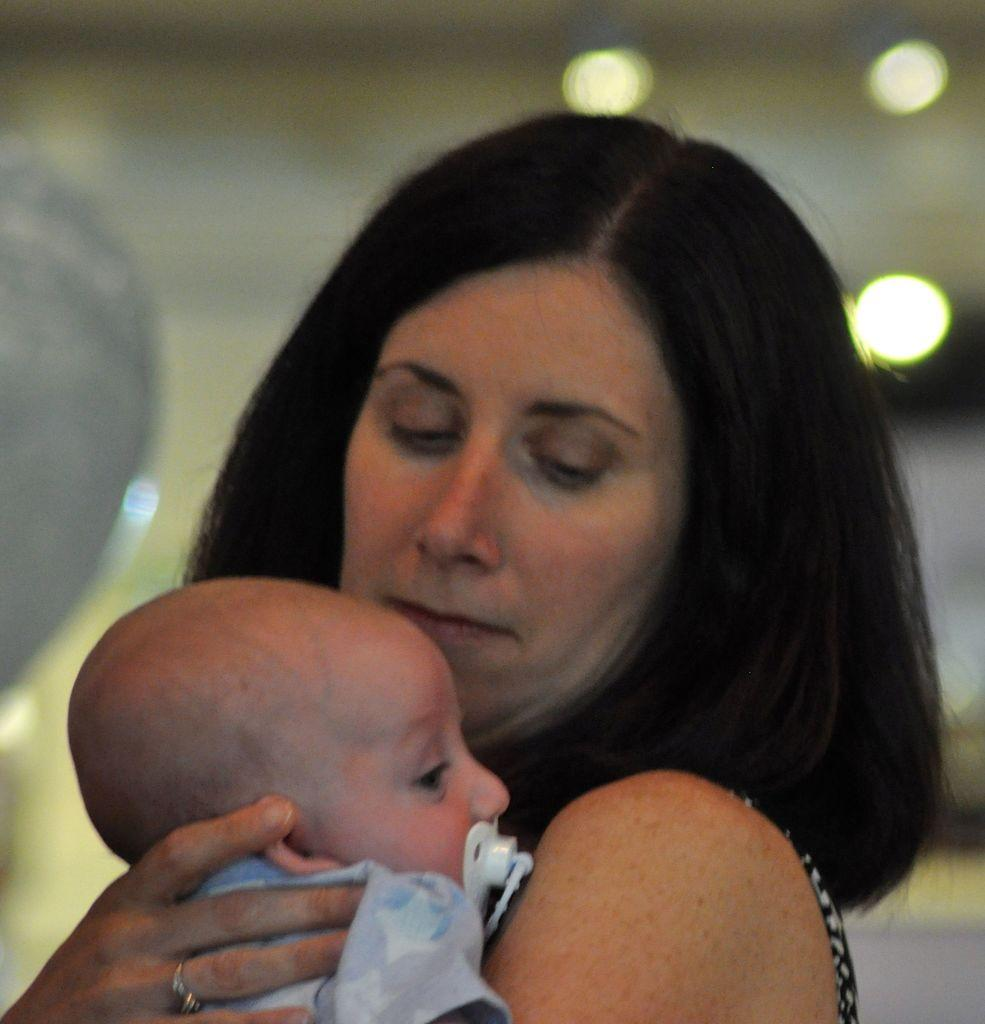What is the main subject of the image? The main subject of the image is a lady. What is the lady doing in the image? The lady is holding a baby. What can be seen in the background of the image? There are lights visible in the background of the image. What type of organization is depicted in the image? There is no organization present in the image; it features a lady holding a baby. How many boats can be seen in the image? There are no boats present in the image. 